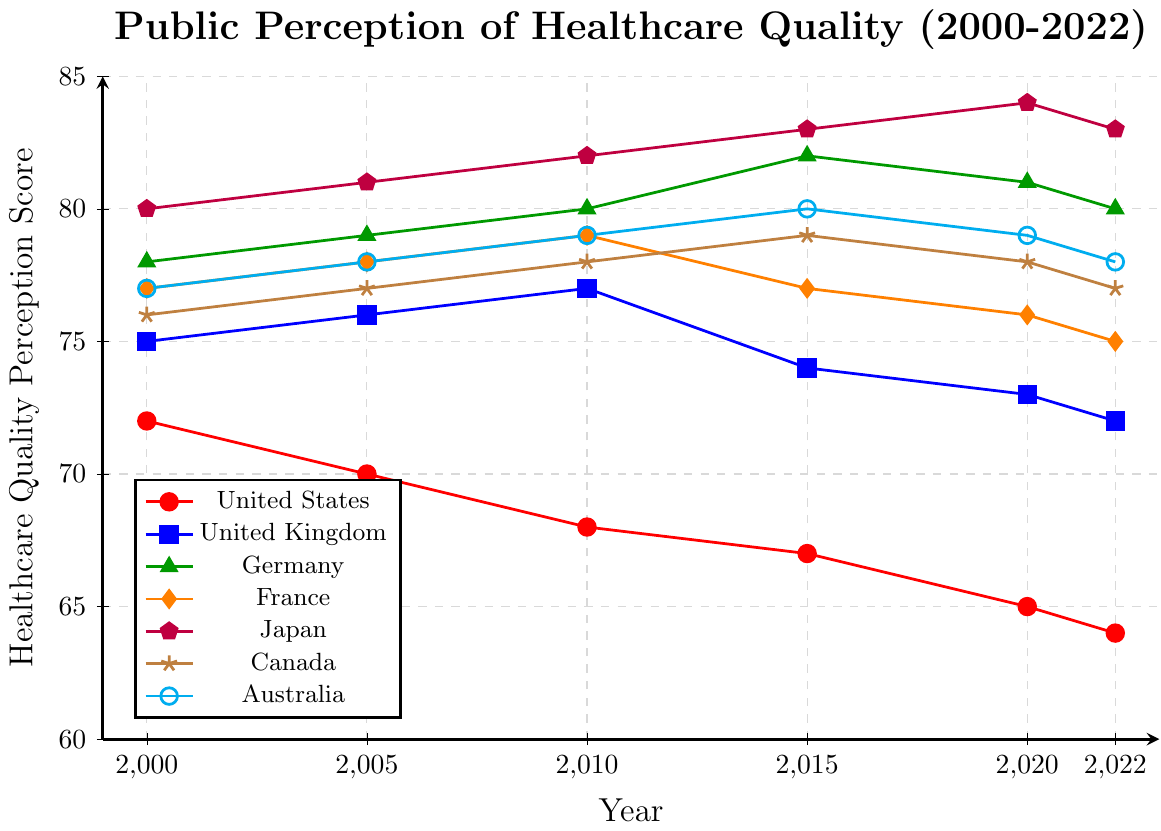Which country had the highest public perception of healthcare quality in 2022? To find this, look at the data points for 2022 and identify the country with the highest score. Japan has the highest score of 83 in 2022.
Answer: Japan Which country experienced the largest decrease in public perception of healthcare quality from 2000 to 2022? Calculate the difference between 2000 and 2022 for each country, and then identify the largest negative difference. For the USA, it's 72 - 64 = 8, which is the largest decrease.
Answer: United States What is the average healthcare quality perception score of Canada from 2000 to 2022? Sum the scores from 2000, 2005, 2010, 2015, 2020, and 2022, then divide by the number of years (6). (76+77+78+79+78+77) / 6 = 77.5.
Answer: 77.5 In which year did Germany record its peak public perception of healthcare quality? Look at Germany's data points from 2000 to 2022 and identify the highest score, which occurs in 2015 with a score of 82.
Answer: 2015 Compare the healthcare quality perception scores of France and Australia in 2020. Which country had a higher score? Look at the scores for both countries in 2020. France has a score of 76, while Australia has a score of 79. Australia has a higher score.
Answer: Australia Which country showed a consistent increase in public perception of healthcare quality until 2020, before a slight drop in 2022? Identify the country with consistently increasing scores followed by a small drop in 2022. Japan's scores increase from 80 (2000) to 84 (2020) and then drop to 83 (2022).
Answer: Japan How many countries had a public perception of healthcare quality score above 80 at any time between 2000 and 2022? Check each country's data points from 2000 to 2022 and count how many had scores above 80. Germany, Japan, and Australia had scores above 80.
Answer: 3 What is the trend in public perception of healthcare quality for the United States from 2000 to 2022? Observe the score changes for the United States from 2000 to 2022. The score consistently declines from 72 in 2000 to 64 in 2022.
Answer: Declining 